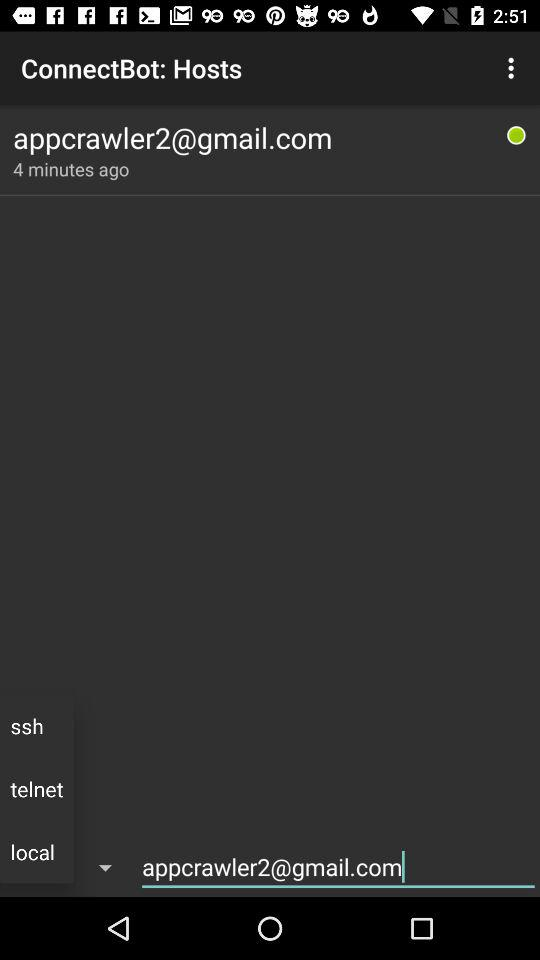When is the host last updated? The host is last updated 4 minutes ago. 